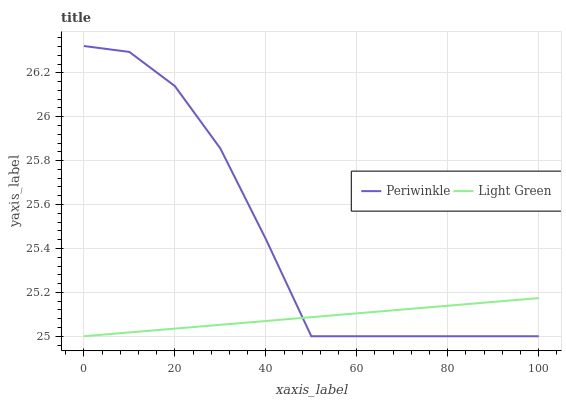Does Light Green have the minimum area under the curve?
Answer yes or no. Yes. Does Periwinkle have the maximum area under the curve?
Answer yes or no. Yes. Does Light Green have the maximum area under the curve?
Answer yes or no. No. Is Light Green the smoothest?
Answer yes or no. Yes. Is Periwinkle the roughest?
Answer yes or no. Yes. Is Light Green the roughest?
Answer yes or no. No. Does Periwinkle have the highest value?
Answer yes or no. Yes. Does Light Green have the highest value?
Answer yes or no. No. Does Light Green intersect Periwinkle?
Answer yes or no. Yes. Is Light Green less than Periwinkle?
Answer yes or no. No. Is Light Green greater than Periwinkle?
Answer yes or no. No. 